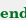Convert code to text. <code><loc_0><loc_0><loc_500><loc_500><_Elixir_>end
</code> 